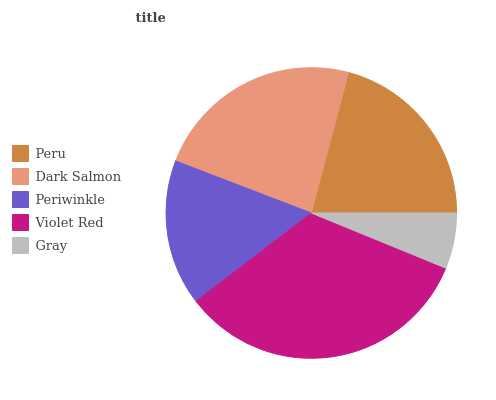Is Gray the minimum?
Answer yes or no. Yes. Is Violet Red the maximum?
Answer yes or no. Yes. Is Dark Salmon the minimum?
Answer yes or no. No. Is Dark Salmon the maximum?
Answer yes or no. No. Is Dark Salmon greater than Peru?
Answer yes or no. Yes. Is Peru less than Dark Salmon?
Answer yes or no. Yes. Is Peru greater than Dark Salmon?
Answer yes or no. No. Is Dark Salmon less than Peru?
Answer yes or no. No. Is Peru the high median?
Answer yes or no. Yes. Is Peru the low median?
Answer yes or no. Yes. Is Violet Red the high median?
Answer yes or no. No. Is Violet Red the low median?
Answer yes or no. No. 